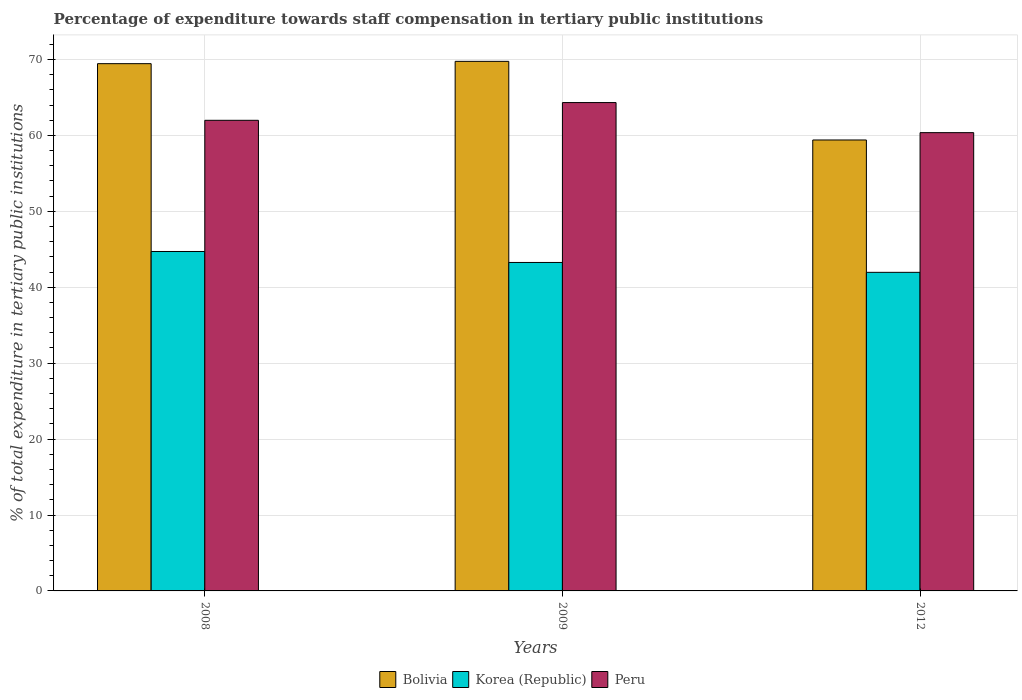How many different coloured bars are there?
Ensure brevity in your answer.  3. How many bars are there on the 2nd tick from the left?
Offer a terse response. 3. What is the percentage of expenditure towards staff compensation in Peru in 2009?
Your answer should be very brief. 64.33. Across all years, what is the maximum percentage of expenditure towards staff compensation in Korea (Republic)?
Your answer should be compact. 44.71. Across all years, what is the minimum percentage of expenditure towards staff compensation in Bolivia?
Ensure brevity in your answer.  59.4. In which year was the percentage of expenditure towards staff compensation in Peru maximum?
Your answer should be compact. 2009. What is the total percentage of expenditure towards staff compensation in Peru in the graph?
Your answer should be compact. 186.69. What is the difference between the percentage of expenditure towards staff compensation in Bolivia in 2009 and that in 2012?
Keep it short and to the point. 10.36. What is the difference between the percentage of expenditure towards staff compensation in Korea (Republic) in 2008 and the percentage of expenditure towards staff compensation in Peru in 2012?
Your answer should be very brief. -15.66. What is the average percentage of expenditure towards staff compensation in Korea (Republic) per year?
Your response must be concise. 43.32. In the year 2008, what is the difference between the percentage of expenditure towards staff compensation in Bolivia and percentage of expenditure towards staff compensation in Korea (Republic)?
Offer a terse response. 24.74. In how many years, is the percentage of expenditure towards staff compensation in Korea (Republic) greater than 32 %?
Your response must be concise. 3. What is the ratio of the percentage of expenditure towards staff compensation in Peru in 2008 to that in 2009?
Your response must be concise. 0.96. Is the percentage of expenditure towards staff compensation in Peru in 2008 less than that in 2012?
Keep it short and to the point. No. What is the difference between the highest and the second highest percentage of expenditure towards staff compensation in Peru?
Keep it short and to the point. 2.34. What is the difference between the highest and the lowest percentage of expenditure towards staff compensation in Korea (Republic)?
Your answer should be very brief. 2.74. What does the 1st bar from the right in 2009 represents?
Your answer should be compact. Peru. Are all the bars in the graph horizontal?
Give a very brief answer. No. Are the values on the major ticks of Y-axis written in scientific E-notation?
Your answer should be very brief. No. Does the graph contain any zero values?
Keep it short and to the point. No. Where does the legend appear in the graph?
Provide a succinct answer. Bottom center. How are the legend labels stacked?
Your answer should be very brief. Horizontal. What is the title of the graph?
Your response must be concise. Percentage of expenditure towards staff compensation in tertiary public institutions. What is the label or title of the X-axis?
Ensure brevity in your answer.  Years. What is the label or title of the Y-axis?
Your answer should be very brief. % of total expenditure in tertiary public institutions. What is the % of total expenditure in tertiary public institutions of Bolivia in 2008?
Your response must be concise. 69.46. What is the % of total expenditure in tertiary public institutions in Korea (Republic) in 2008?
Provide a short and direct response. 44.71. What is the % of total expenditure in tertiary public institutions of Peru in 2008?
Make the answer very short. 61.99. What is the % of total expenditure in tertiary public institutions in Bolivia in 2009?
Offer a very short reply. 69.76. What is the % of total expenditure in tertiary public institutions of Korea (Republic) in 2009?
Provide a succinct answer. 43.27. What is the % of total expenditure in tertiary public institutions in Peru in 2009?
Keep it short and to the point. 64.33. What is the % of total expenditure in tertiary public institutions in Bolivia in 2012?
Make the answer very short. 59.4. What is the % of total expenditure in tertiary public institutions of Korea (Republic) in 2012?
Provide a short and direct response. 41.97. What is the % of total expenditure in tertiary public institutions of Peru in 2012?
Keep it short and to the point. 60.37. Across all years, what is the maximum % of total expenditure in tertiary public institutions in Bolivia?
Your answer should be compact. 69.76. Across all years, what is the maximum % of total expenditure in tertiary public institutions in Korea (Republic)?
Make the answer very short. 44.71. Across all years, what is the maximum % of total expenditure in tertiary public institutions of Peru?
Ensure brevity in your answer.  64.33. Across all years, what is the minimum % of total expenditure in tertiary public institutions of Bolivia?
Your response must be concise. 59.4. Across all years, what is the minimum % of total expenditure in tertiary public institutions of Korea (Republic)?
Offer a terse response. 41.97. Across all years, what is the minimum % of total expenditure in tertiary public institutions in Peru?
Your answer should be compact. 60.37. What is the total % of total expenditure in tertiary public institutions of Bolivia in the graph?
Offer a terse response. 198.62. What is the total % of total expenditure in tertiary public institutions in Korea (Republic) in the graph?
Offer a very short reply. 129.95. What is the total % of total expenditure in tertiary public institutions in Peru in the graph?
Offer a very short reply. 186.69. What is the difference between the % of total expenditure in tertiary public institutions in Bolivia in 2008 and that in 2009?
Keep it short and to the point. -0.3. What is the difference between the % of total expenditure in tertiary public institutions of Korea (Republic) in 2008 and that in 2009?
Ensure brevity in your answer.  1.44. What is the difference between the % of total expenditure in tertiary public institutions of Peru in 2008 and that in 2009?
Keep it short and to the point. -2.34. What is the difference between the % of total expenditure in tertiary public institutions of Bolivia in 2008 and that in 2012?
Your response must be concise. 10.05. What is the difference between the % of total expenditure in tertiary public institutions of Korea (Republic) in 2008 and that in 2012?
Offer a terse response. 2.74. What is the difference between the % of total expenditure in tertiary public institutions in Peru in 2008 and that in 2012?
Offer a terse response. 1.63. What is the difference between the % of total expenditure in tertiary public institutions in Bolivia in 2009 and that in 2012?
Provide a succinct answer. 10.36. What is the difference between the % of total expenditure in tertiary public institutions of Korea (Republic) in 2009 and that in 2012?
Offer a terse response. 1.3. What is the difference between the % of total expenditure in tertiary public institutions of Peru in 2009 and that in 2012?
Offer a terse response. 3.96. What is the difference between the % of total expenditure in tertiary public institutions of Bolivia in 2008 and the % of total expenditure in tertiary public institutions of Korea (Republic) in 2009?
Offer a very short reply. 26.19. What is the difference between the % of total expenditure in tertiary public institutions in Bolivia in 2008 and the % of total expenditure in tertiary public institutions in Peru in 2009?
Provide a short and direct response. 5.12. What is the difference between the % of total expenditure in tertiary public institutions of Korea (Republic) in 2008 and the % of total expenditure in tertiary public institutions of Peru in 2009?
Keep it short and to the point. -19.62. What is the difference between the % of total expenditure in tertiary public institutions in Bolivia in 2008 and the % of total expenditure in tertiary public institutions in Korea (Republic) in 2012?
Make the answer very short. 27.49. What is the difference between the % of total expenditure in tertiary public institutions of Bolivia in 2008 and the % of total expenditure in tertiary public institutions of Peru in 2012?
Your answer should be compact. 9.09. What is the difference between the % of total expenditure in tertiary public institutions in Korea (Republic) in 2008 and the % of total expenditure in tertiary public institutions in Peru in 2012?
Your answer should be very brief. -15.66. What is the difference between the % of total expenditure in tertiary public institutions of Bolivia in 2009 and the % of total expenditure in tertiary public institutions of Korea (Republic) in 2012?
Ensure brevity in your answer.  27.79. What is the difference between the % of total expenditure in tertiary public institutions in Bolivia in 2009 and the % of total expenditure in tertiary public institutions in Peru in 2012?
Provide a short and direct response. 9.39. What is the difference between the % of total expenditure in tertiary public institutions of Korea (Republic) in 2009 and the % of total expenditure in tertiary public institutions of Peru in 2012?
Ensure brevity in your answer.  -17.1. What is the average % of total expenditure in tertiary public institutions in Bolivia per year?
Offer a very short reply. 66.21. What is the average % of total expenditure in tertiary public institutions in Korea (Republic) per year?
Offer a very short reply. 43.32. What is the average % of total expenditure in tertiary public institutions in Peru per year?
Offer a terse response. 62.23. In the year 2008, what is the difference between the % of total expenditure in tertiary public institutions in Bolivia and % of total expenditure in tertiary public institutions in Korea (Republic)?
Provide a succinct answer. 24.74. In the year 2008, what is the difference between the % of total expenditure in tertiary public institutions in Bolivia and % of total expenditure in tertiary public institutions in Peru?
Provide a succinct answer. 7.46. In the year 2008, what is the difference between the % of total expenditure in tertiary public institutions of Korea (Republic) and % of total expenditure in tertiary public institutions of Peru?
Your answer should be compact. -17.28. In the year 2009, what is the difference between the % of total expenditure in tertiary public institutions of Bolivia and % of total expenditure in tertiary public institutions of Korea (Republic)?
Provide a succinct answer. 26.49. In the year 2009, what is the difference between the % of total expenditure in tertiary public institutions in Bolivia and % of total expenditure in tertiary public institutions in Peru?
Keep it short and to the point. 5.43. In the year 2009, what is the difference between the % of total expenditure in tertiary public institutions in Korea (Republic) and % of total expenditure in tertiary public institutions in Peru?
Keep it short and to the point. -21.06. In the year 2012, what is the difference between the % of total expenditure in tertiary public institutions in Bolivia and % of total expenditure in tertiary public institutions in Korea (Republic)?
Offer a very short reply. 17.43. In the year 2012, what is the difference between the % of total expenditure in tertiary public institutions in Bolivia and % of total expenditure in tertiary public institutions in Peru?
Your answer should be very brief. -0.97. In the year 2012, what is the difference between the % of total expenditure in tertiary public institutions in Korea (Republic) and % of total expenditure in tertiary public institutions in Peru?
Offer a very short reply. -18.4. What is the ratio of the % of total expenditure in tertiary public institutions in Korea (Republic) in 2008 to that in 2009?
Your response must be concise. 1.03. What is the ratio of the % of total expenditure in tertiary public institutions in Peru in 2008 to that in 2009?
Your response must be concise. 0.96. What is the ratio of the % of total expenditure in tertiary public institutions of Bolivia in 2008 to that in 2012?
Offer a terse response. 1.17. What is the ratio of the % of total expenditure in tertiary public institutions of Korea (Republic) in 2008 to that in 2012?
Keep it short and to the point. 1.07. What is the ratio of the % of total expenditure in tertiary public institutions of Peru in 2008 to that in 2012?
Your answer should be compact. 1.03. What is the ratio of the % of total expenditure in tertiary public institutions in Bolivia in 2009 to that in 2012?
Offer a terse response. 1.17. What is the ratio of the % of total expenditure in tertiary public institutions in Korea (Republic) in 2009 to that in 2012?
Your answer should be compact. 1.03. What is the ratio of the % of total expenditure in tertiary public institutions of Peru in 2009 to that in 2012?
Offer a terse response. 1.07. What is the difference between the highest and the second highest % of total expenditure in tertiary public institutions in Bolivia?
Make the answer very short. 0.3. What is the difference between the highest and the second highest % of total expenditure in tertiary public institutions of Korea (Republic)?
Your answer should be compact. 1.44. What is the difference between the highest and the second highest % of total expenditure in tertiary public institutions of Peru?
Offer a terse response. 2.34. What is the difference between the highest and the lowest % of total expenditure in tertiary public institutions in Bolivia?
Offer a terse response. 10.36. What is the difference between the highest and the lowest % of total expenditure in tertiary public institutions in Korea (Republic)?
Make the answer very short. 2.74. What is the difference between the highest and the lowest % of total expenditure in tertiary public institutions in Peru?
Ensure brevity in your answer.  3.96. 